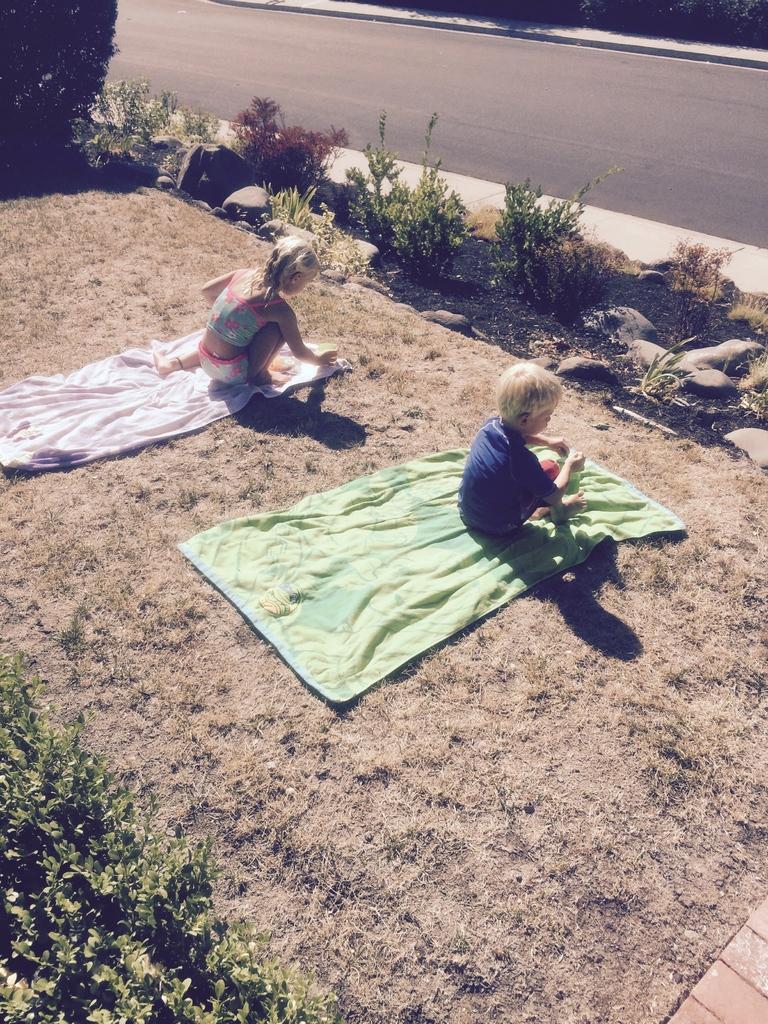Can you describe this image briefly? In this image there is road, there are plantś, there are two childrenś, there is a blanket on the ground. 